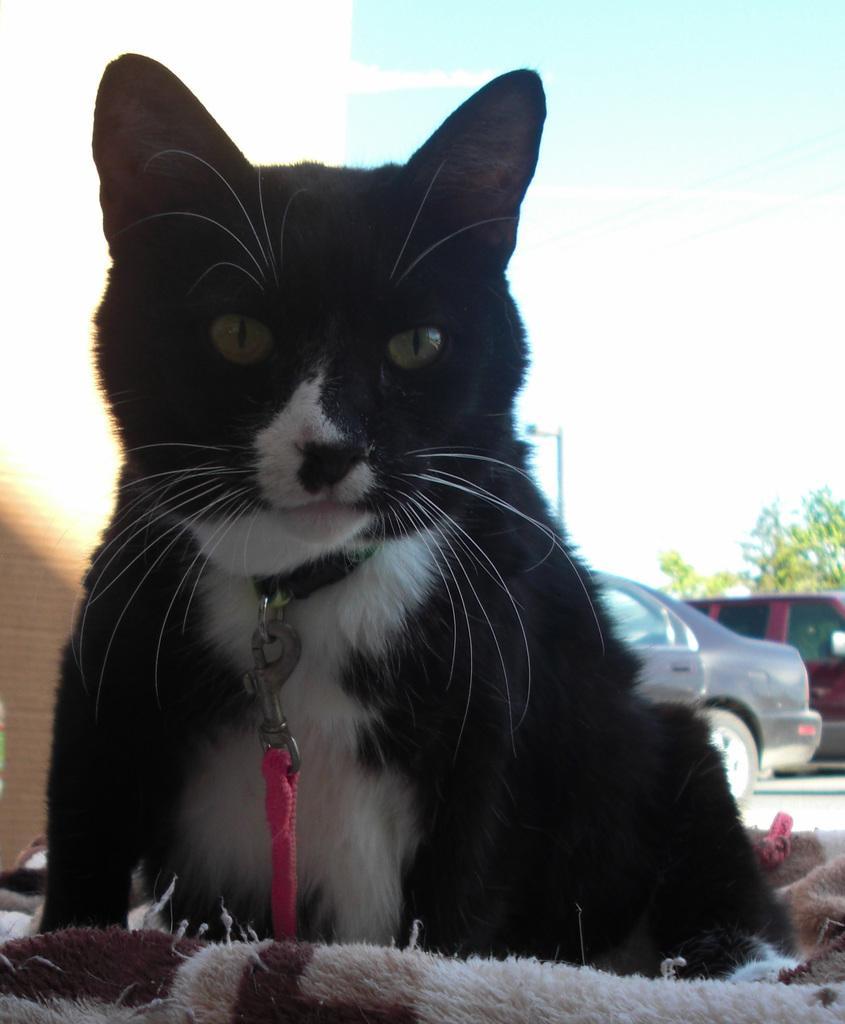Could you give a brief overview of what you see in this image? in the center of the image we can see a cat. At the bottom there is a cloth. In the background there are cars. On the left there is a wall and we can see a pole and a tree. At the top there is sky. 